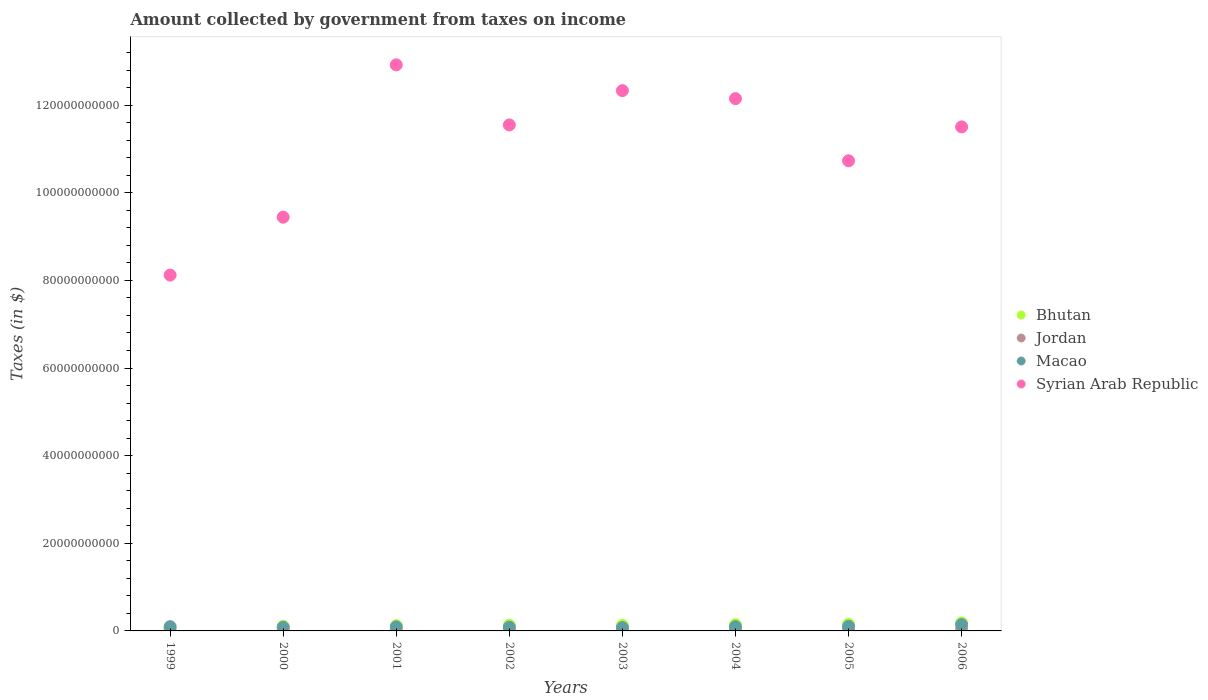How many different coloured dotlines are there?
Give a very brief answer. 4. Is the number of dotlines equal to the number of legend labels?
Your answer should be very brief. Yes. What is the amount collected by government from taxes on income in Syrian Arab Republic in 1999?
Give a very brief answer. 8.12e+1. Across all years, what is the maximum amount collected by government from taxes on income in Bhutan?
Give a very brief answer. 1.83e+09. Across all years, what is the minimum amount collected by government from taxes on income in Macao?
Offer a very short reply. 7.81e+08. What is the total amount collected by government from taxes on income in Bhutan in the graph?
Your answer should be very brief. 1.03e+1. What is the difference between the amount collected by government from taxes on income in Macao in 2000 and that in 2002?
Make the answer very short. -3.52e+07. What is the difference between the amount collected by government from taxes on income in Syrian Arab Republic in 2006 and the amount collected by government from taxes on income in Jordan in 2002?
Keep it short and to the point. 1.15e+11. What is the average amount collected by government from taxes on income in Macao per year?
Ensure brevity in your answer.  9.82e+08. In the year 2001, what is the difference between the amount collected by government from taxes on income in Bhutan and amount collected by government from taxes on income in Jordan?
Ensure brevity in your answer.  9.96e+08. What is the ratio of the amount collected by government from taxes on income in Jordan in 1999 to that in 2006?
Offer a very short reply. 0.37. What is the difference between the highest and the second highest amount collected by government from taxes on income in Syrian Arab Republic?
Offer a terse response. 5.89e+09. What is the difference between the highest and the lowest amount collected by government from taxes on income in Bhutan?
Ensure brevity in your answer.  1.11e+09. In how many years, is the amount collected by government from taxes on income in Bhutan greater than the average amount collected by government from taxes on income in Bhutan taken over all years?
Keep it short and to the point. 4. Is the amount collected by government from taxes on income in Macao strictly greater than the amount collected by government from taxes on income in Bhutan over the years?
Provide a short and direct response. No. Is the amount collected by government from taxes on income in Syrian Arab Republic strictly less than the amount collected by government from taxes on income in Macao over the years?
Ensure brevity in your answer.  No. How many dotlines are there?
Your answer should be very brief. 4. How many years are there in the graph?
Make the answer very short. 8. Are the values on the major ticks of Y-axis written in scientific E-notation?
Ensure brevity in your answer.  No. Does the graph contain grids?
Your response must be concise. No. How many legend labels are there?
Give a very brief answer. 4. What is the title of the graph?
Your answer should be very brief. Amount collected by government from taxes on income. Does "Chile" appear as one of the legend labels in the graph?
Your answer should be very brief. No. What is the label or title of the X-axis?
Offer a terse response. Years. What is the label or title of the Y-axis?
Ensure brevity in your answer.  Taxes (in $). What is the Taxes (in $) of Bhutan in 1999?
Offer a terse response. 7.25e+08. What is the Taxes (in $) in Jordan in 1999?
Offer a very short reply. 1.53e+08. What is the Taxes (in $) in Macao in 1999?
Make the answer very short. 9.76e+08. What is the Taxes (in $) of Syrian Arab Republic in 1999?
Your answer should be very brief. 8.12e+1. What is the Taxes (in $) in Bhutan in 2000?
Offer a terse response. 1.06e+09. What is the Taxes (in $) in Jordan in 2000?
Offer a very short reply. 1.61e+08. What is the Taxes (in $) in Macao in 2000?
Your response must be concise. 8.38e+08. What is the Taxes (in $) of Syrian Arab Republic in 2000?
Your answer should be compact. 9.44e+1. What is the Taxes (in $) in Bhutan in 2001?
Provide a succinct answer. 1.19e+09. What is the Taxes (in $) in Jordan in 2001?
Make the answer very short. 1.95e+08. What is the Taxes (in $) of Macao in 2001?
Provide a succinct answer. 9.24e+08. What is the Taxes (in $) in Syrian Arab Republic in 2001?
Offer a terse response. 1.29e+11. What is the Taxes (in $) of Bhutan in 2002?
Give a very brief answer. 1.31e+09. What is the Taxes (in $) of Jordan in 2002?
Your response must be concise. 1.96e+08. What is the Taxes (in $) of Macao in 2002?
Your answer should be compact. 8.73e+08. What is the Taxes (in $) of Syrian Arab Republic in 2002?
Give a very brief answer. 1.15e+11. What is the Taxes (in $) of Bhutan in 2003?
Give a very brief answer. 1.27e+09. What is the Taxes (in $) of Jordan in 2003?
Your response must be concise. 1.95e+08. What is the Taxes (in $) in Macao in 2003?
Offer a terse response. 7.81e+08. What is the Taxes (in $) of Syrian Arab Republic in 2003?
Offer a very short reply. 1.23e+11. What is the Taxes (in $) of Bhutan in 2004?
Your response must be concise. 1.42e+09. What is the Taxes (in $) in Jordan in 2004?
Offer a very short reply. 2.18e+08. What is the Taxes (in $) of Macao in 2004?
Provide a succinct answer. 9.68e+08. What is the Taxes (in $) in Syrian Arab Republic in 2004?
Offer a terse response. 1.21e+11. What is the Taxes (in $) of Bhutan in 2005?
Provide a short and direct response. 1.53e+09. What is the Taxes (in $) in Jordan in 2005?
Your answer should be very brief. 2.84e+08. What is the Taxes (in $) in Macao in 2005?
Keep it short and to the point. 1.05e+09. What is the Taxes (in $) in Syrian Arab Republic in 2005?
Your answer should be very brief. 1.07e+11. What is the Taxes (in $) of Bhutan in 2006?
Your answer should be compact. 1.83e+09. What is the Taxes (in $) of Jordan in 2006?
Offer a very short reply. 4.11e+08. What is the Taxes (in $) of Macao in 2006?
Offer a very short reply. 1.45e+09. What is the Taxes (in $) of Syrian Arab Republic in 2006?
Make the answer very short. 1.15e+11. Across all years, what is the maximum Taxes (in $) of Bhutan?
Offer a terse response. 1.83e+09. Across all years, what is the maximum Taxes (in $) in Jordan?
Ensure brevity in your answer.  4.11e+08. Across all years, what is the maximum Taxes (in $) in Macao?
Give a very brief answer. 1.45e+09. Across all years, what is the maximum Taxes (in $) of Syrian Arab Republic?
Your answer should be very brief. 1.29e+11. Across all years, what is the minimum Taxes (in $) of Bhutan?
Make the answer very short. 7.25e+08. Across all years, what is the minimum Taxes (in $) of Jordan?
Your answer should be compact. 1.53e+08. Across all years, what is the minimum Taxes (in $) in Macao?
Your response must be concise. 7.81e+08. Across all years, what is the minimum Taxes (in $) of Syrian Arab Republic?
Your answer should be compact. 8.12e+1. What is the total Taxes (in $) of Bhutan in the graph?
Provide a short and direct response. 1.03e+1. What is the total Taxes (in $) of Jordan in the graph?
Provide a short and direct response. 1.81e+09. What is the total Taxes (in $) of Macao in the graph?
Ensure brevity in your answer.  7.86e+09. What is the total Taxes (in $) in Syrian Arab Republic in the graph?
Make the answer very short. 8.87e+11. What is the difference between the Taxes (in $) of Bhutan in 1999 and that in 2000?
Keep it short and to the point. -3.32e+08. What is the difference between the Taxes (in $) of Jordan in 1999 and that in 2000?
Give a very brief answer. -8.20e+06. What is the difference between the Taxes (in $) of Macao in 1999 and that in 2000?
Your answer should be compact. 1.38e+08. What is the difference between the Taxes (in $) in Syrian Arab Republic in 1999 and that in 2000?
Your response must be concise. -1.32e+1. What is the difference between the Taxes (in $) of Bhutan in 1999 and that in 2001?
Provide a short and direct response. -4.67e+08. What is the difference between the Taxes (in $) of Jordan in 1999 and that in 2001?
Keep it short and to the point. -4.26e+07. What is the difference between the Taxes (in $) of Macao in 1999 and that in 2001?
Provide a succinct answer. 5.21e+07. What is the difference between the Taxes (in $) in Syrian Arab Republic in 1999 and that in 2001?
Make the answer very short. -4.80e+1. What is the difference between the Taxes (in $) in Bhutan in 1999 and that in 2002?
Keep it short and to the point. -5.80e+08. What is the difference between the Taxes (in $) of Jordan in 1999 and that in 2002?
Give a very brief answer. -4.34e+07. What is the difference between the Taxes (in $) of Macao in 1999 and that in 2002?
Offer a terse response. 1.03e+08. What is the difference between the Taxes (in $) of Syrian Arab Republic in 1999 and that in 2002?
Your answer should be compact. -3.43e+1. What is the difference between the Taxes (in $) in Bhutan in 1999 and that in 2003?
Ensure brevity in your answer.  -5.48e+08. What is the difference between the Taxes (in $) of Jordan in 1999 and that in 2003?
Keep it short and to the point. -4.26e+07. What is the difference between the Taxes (in $) in Macao in 1999 and that in 2003?
Offer a terse response. 1.95e+08. What is the difference between the Taxes (in $) in Syrian Arab Republic in 1999 and that in 2003?
Offer a very short reply. -4.21e+1. What is the difference between the Taxes (in $) in Bhutan in 1999 and that in 2004?
Offer a terse response. -6.94e+08. What is the difference between the Taxes (in $) in Jordan in 1999 and that in 2004?
Provide a short and direct response. -6.51e+07. What is the difference between the Taxes (in $) of Macao in 1999 and that in 2004?
Offer a terse response. 8.38e+06. What is the difference between the Taxes (in $) in Syrian Arab Republic in 1999 and that in 2004?
Provide a succinct answer. -4.03e+1. What is the difference between the Taxes (in $) of Bhutan in 1999 and that in 2005?
Your answer should be very brief. -8.05e+08. What is the difference between the Taxes (in $) of Jordan in 1999 and that in 2005?
Make the answer very short. -1.31e+08. What is the difference between the Taxes (in $) in Macao in 1999 and that in 2005?
Keep it short and to the point. -7.70e+07. What is the difference between the Taxes (in $) in Syrian Arab Republic in 1999 and that in 2005?
Your response must be concise. -2.61e+1. What is the difference between the Taxes (in $) of Bhutan in 1999 and that in 2006?
Make the answer very short. -1.11e+09. What is the difference between the Taxes (in $) in Jordan in 1999 and that in 2006?
Offer a very short reply. -2.59e+08. What is the difference between the Taxes (in $) of Macao in 1999 and that in 2006?
Keep it short and to the point. -4.70e+08. What is the difference between the Taxes (in $) of Syrian Arab Republic in 1999 and that in 2006?
Ensure brevity in your answer.  -3.38e+1. What is the difference between the Taxes (in $) of Bhutan in 2000 and that in 2001?
Your response must be concise. -1.35e+08. What is the difference between the Taxes (in $) in Jordan in 2000 and that in 2001?
Make the answer very short. -3.44e+07. What is the difference between the Taxes (in $) of Macao in 2000 and that in 2001?
Keep it short and to the point. -8.57e+07. What is the difference between the Taxes (in $) of Syrian Arab Republic in 2000 and that in 2001?
Your answer should be compact. -3.48e+1. What is the difference between the Taxes (in $) in Bhutan in 2000 and that in 2002?
Keep it short and to the point. -2.48e+08. What is the difference between the Taxes (in $) of Jordan in 2000 and that in 2002?
Your answer should be compact. -3.52e+07. What is the difference between the Taxes (in $) in Macao in 2000 and that in 2002?
Offer a very short reply. -3.52e+07. What is the difference between the Taxes (in $) in Syrian Arab Republic in 2000 and that in 2002?
Your response must be concise. -2.11e+1. What is the difference between the Taxes (in $) of Bhutan in 2000 and that in 2003?
Offer a very short reply. -2.16e+08. What is the difference between the Taxes (in $) of Jordan in 2000 and that in 2003?
Make the answer very short. -3.44e+07. What is the difference between the Taxes (in $) in Macao in 2000 and that in 2003?
Make the answer very short. 5.73e+07. What is the difference between the Taxes (in $) of Syrian Arab Republic in 2000 and that in 2003?
Give a very brief answer. -2.89e+1. What is the difference between the Taxes (in $) in Bhutan in 2000 and that in 2004?
Make the answer very short. -3.63e+08. What is the difference between the Taxes (in $) of Jordan in 2000 and that in 2004?
Offer a terse response. -5.69e+07. What is the difference between the Taxes (in $) in Macao in 2000 and that in 2004?
Your answer should be very brief. -1.29e+08. What is the difference between the Taxes (in $) in Syrian Arab Republic in 2000 and that in 2004?
Keep it short and to the point. -2.71e+1. What is the difference between the Taxes (in $) of Bhutan in 2000 and that in 2005?
Provide a succinct answer. -4.73e+08. What is the difference between the Taxes (in $) of Jordan in 2000 and that in 2005?
Provide a short and direct response. -1.23e+08. What is the difference between the Taxes (in $) of Macao in 2000 and that in 2005?
Ensure brevity in your answer.  -2.15e+08. What is the difference between the Taxes (in $) of Syrian Arab Republic in 2000 and that in 2005?
Provide a succinct answer. -1.29e+1. What is the difference between the Taxes (in $) of Bhutan in 2000 and that in 2006?
Your answer should be very brief. -7.76e+08. What is the difference between the Taxes (in $) of Jordan in 2000 and that in 2006?
Ensure brevity in your answer.  -2.50e+08. What is the difference between the Taxes (in $) in Macao in 2000 and that in 2006?
Give a very brief answer. -6.08e+08. What is the difference between the Taxes (in $) in Syrian Arab Republic in 2000 and that in 2006?
Keep it short and to the point. -2.06e+1. What is the difference between the Taxes (in $) in Bhutan in 2001 and that in 2002?
Provide a short and direct response. -1.13e+08. What is the difference between the Taxes (in $) of Jordan in 2001 and that in 2002?
Your response must be concise. -8.00e+05. What is the difference between the Taxes (in $) of Macao in 2001 and that in 2002?
Your answer should be very brief. 5.05e+07. What is the difference between the Taxes (in $) of Syrian Arab Republic in 2001 and that in 2002?
Provide a short and direct response. 1.37e+1. What is the difference between the Taxes (in $) of Bhutan in 2001 and that in 2003?
Ensure brevity in your answer.  -8.09e+07. What is the difference between the Taxes (in $) of Macao in 2001 and that in 2003?
Provide a short and direct response. 1.43e+08. What is the difference between the Taxes (in $) in Syrian Arab Republic in 2001 and that in 2003?
Your answer should be very brief. 5.89e+09. What is the difference between the Taxes (in $) in Bhutan in 2001 and that in 2004?
Offer a very short reply. -2.28e+08. What is the difference between the Taxes (in $) in Jordan in 2001 and that in 2004?
Your answer should be compact. -2.25e+07. What is the difference between the Taxes (in $) in Macao in 2001 and that in 2004?
Give a very brief answer. -4.38e+07. What is the difference between the Taxes (in $) of Syrian Arab Republic in 2001 and that in 2004?
Provide a succinct answer. 7.71e+09. What is the difference between the Taxes (in $) in Bhutan in 2001 and that in 2005?
Make the answer very short. -3.38e+08. What is the difference between the Taxes (in $) in Jordan in 2001 and that in 2005?
Offer a terse response. -8.83e+07. What is the difference between the Taxes (in $) in Macao in 2001 and that in 2005?
Offer a very short reply. -1.29e+08. What is the difference between the Taxes (in $) in Syrian Arab Republic in 2001 and that in 2005?
Offer a very short reply. 2.19e+1. What is the difference between the Taxes (in $) in Bhutan in 2001 and that in 2006?
Your answer should be very brief. -6.41e+08. What is the difference between the Taxes (in $) of Jordan in 2001 and that in 2006?
Your answer should be very brief. -2.16e+08. What is the difference between the Taxes (in $) in Macao in 2001 and that in 2006?
Give a very brief answer. -5.22e+08. What is the difference between the Taxes (in $) in Syrian Arab Republic in 2001 and that in 2006?
Your response must be concise. 1.42e+1. What is the difference between the Taxes (in $) of Bhutan in 2002 and that in 2003?
Your answer should be compact. 3.24e+07. What is the difference between the Taxes (in $) of Jordan in 2002 and that in 2003?
Offer a terse response. 8.20e+05. What is the difference between the Taxes (in $) in Macao in 2002 and that in 2003?
Provide a short and direct response. 9.25e+07. What is the difference between the Taxes (in $) in Syrian Arab Republic in 2002 and that in 2003?
Offer a very short reply. -7.82e+09. What is the difference between the Taxes (in $) in Bhutan in 2002 and that in 2004?
Give a very brief answer. -1.14e+08. What is the difference between the Taxes (in $) in Jordan in 2002 and that in 2004?
Your answer should be very brief. -2.17e+07. What is the difference between the Taxes (in $) in Macao in 2002 and that in 2004?
Provide a succinct answer. -9.42e+07. What is the difference between the Taxes (in $) of Syrian Arab Republic in 2002 and that in 2004?
Your answer should be very brief. -6.00e+09. What is the difference between the Taxes (in $) of Bhutan in 2002 and that in 2005?
Ensure brevity in your answer.  -2.25e+08. What is the difference between the Taxes (in $) in Jordan in 2002 and that in 2005?
Make the answer very short. -8.75e+07. What is the difference between the Taxes (in $) of Macao in 2002 and that in 2005?
Provide a short and direct response. -1.80e+08. What is the difference between the Taxes (in $) of Syrian Arab Republic in 2002 and that in 2005?
Your answer should be compact. 8.18e+09. What is the difference between the Taxes (in $) of Bhutan in 2002 and that in 2006?
Make the answer very short. -5.28e+08. What is the difference between the Taxes (in $) in Jordan in 2002 and that in 2006?
Ensure brevity in your answer.  -2.15e+08. What is the difference between the Taxes (in $) in Macao in 2002 and that in 2006?
Your answer should be compact. -5.73e+08. What is the difference between the Taxes (in $) in Syrian Arab Republic in 2002 and that in 2006?
Keep it short and to the point. 4.52e+08. What is the difference between the Taxes (in $) of Bhutan in 2003 and that in 2004?
Keep it short and to the point. -1.47e+08. What is the difference between the Taxes (in $) of Jordan in 2003 and that in 2004?
Provide a succinct answer. -2.25e+07. What is the difference between the Taxes (in $) of Macao in 2003 and that in 2004?
Your answer should be very brief. -1.87e+08. What is the difference between the Taxes (in $) in Syrian Arab Republic in 2003 and that in 2004?
Your answer should be very brief. 1.83e+09. What is the difference between the Taxes (in $) of Bhutan in 2003 and that in 2005?
Offer a very short reply. -2.57e+08. What is the difference between the Taxes (in $) of Jordan in 2003 and that in 2005?
Provide a succinct answer. -8.83e+07. What is the difference between the Taxes (in $) in Macao in 2003 and that in 2005?
Your response must be concise. -2.72e+08. What is the difference between the Taxes (in $) in Syrian Arab Republic in 2003 and that in 2005?
Offer a terse response. 1.60e+1. What is the difference between the Taxes (in $) of Bhutan in 2003 and that in 2006?
Your response must be concise. -5.61e+08. What is the difference between the Taxes (in $) of Jordan in 2003 and that in 2006?
Provide a short and direct response. -2.16e+08. What is the difference between the Taxes (in $) of Macao in 2003 and that in 2006?
Offer a very short reply. -6.65e+08. What is the difference between the Taxes (in $) of Syrian Arab Republic in 2003 and that in 2006?
Provide a short and direct response. 8.27e+09. What is the difference between the Taxes (in $) of Bhutan in 2004 and that in 2005?
Give a very brief answer. -1.10e+08. What is the difference between the Taxes (in $) in Jordan in 2004 and that in 2005?
Keep it short and to the point. -6.58e+07. What is the difference between the Taxes (in $) in Macao in 2004 and that in 2005?
Offer a very short reply. -8.54e+07. What is the difference between the Taxes (in $) of Syrian Arab Republic in 2004 and that in 2005?
Offer a very short reply. 1.42e+1. What is the difference between the Taxes (in $) of Bhutan in 2004 and that in 2006?
Offer a very short reply. -4.14e+08. What is the difference between the Taxes (in $) of Jordan in 2004 and that in 2006?
Ensure brevity in your answer.  -1.94e+08. What is the difference between the Taxes (in $) in Macao in 2004 and that in 2006?
Make the answer very short. -4.78e+08. What is the difference between the Taxes (in $) in Syrian Arab Republic in 2004 and that in 2006?
Your answer should be compact. 6.45e+09. What is the difference between the Taxes (in $) in Bhutan in 2005 and that in 2006?
Offer a terse response. -3.03e+08. What is the difference between the Taxes (in $) in Jordan in 2005 and that in 2006?
Provide a succinct answer. -1.28e+08. What is the difference between the Taxes (in $) of Macao in 2005 and that in 2006?
Provide a short and direct response. -3.93e+08. What is the difference between the Taxes (in $) in Syrian Arab Republic in 2005 and that in 2006?
Provide a short and direct response. -7.73e+09. What is the difference between the Taxes (in $) of Bhutan in 1999 and the Taxes (in $) of Jordan in 2000?
Your answer should be compact. 5.64e+08. What is the difference between the Taxes (in $) of Bhutan in 1999 and the Taxes (in $) of Macao in 2000?
Provide a short and direct response. -1.13e+08. What is the difference between the Taxes (in $) in Bhutan in 1999 and the Taxes (in $) in Syrian Arab Republic in 2000?
Offer a very short reply. -9.37e+1. What is the difference between the Taxes (in $) in Jordan in 1999 and the Taxes (in $) in Macao in 2000?
Give a very brief answer. -6.85e+08. What is the difference between the Taxes (in $) in Jordan in 1999 and the Taxes (in $) in Syrian Arab Republic in 2000?
Your response must be concise. -9.43e+1. What is the difference between the Taxes (in $) in Macao in 1999 and the Taxes (in $) in Syrian Arab Republic in 2000?
Make the answer very short. -9.34e+1. What is the difference between the Taxes (in $) of Bhutan in 1999 and the Taxes (in $) of Jordan in 2001?
Your response must be concise. 5.30e+08. What is the difference between the Taxes (in $) of Bhutan in 1999 and the Taxes (in $) of Macao in 2001?
Ensure brevity in your answer.  -1.99e+08. What is the difference between the Taxes (in $) of Bhutan in 1999 and the Taxes (in $) of Syrian Arab Republic in 2001?
Your response must be concise. -1.28e+11. What is the difference between the Taxes (in $) in Jordan in 1999 and the Taxes (in $) in Macao in 2001?
Your answer should be very brief. -7.71e+08. What is the difference between the Taxes (in $) in Jordan in 1999 and the Taxes (in $) in Syrian Arab Republic in 2001?
Your answer should be compact. -1.29e+11. What is the difference between the Taxes (in $) of Macao in 1999 and the Taxes (in $) of Syrian Arab Republic in 2001?
Provide a succinct answer. -1.28e+11. What is the difference between the Taxes (in $) of Bhutan in 1999 and the Taxes (in $) of Jordan in 2002?
Ensure brevity in your answer.  5.29e+08. What is the difference between the Taxes (in $) in Bhutan in 1999 and the Taxes (in $) in Macao in 2002?
Make the answer very short. -1.48e+08. What is the difference between the Taxes (in $) in Bhutan in 1999 and the Taxes (in $) in Syrian Arab Republic in 2002?
Provide a short and direct response. -1.15e+11. What is the difference between the Taxes (in $) in Jordan in 1999 and the Taxes (in $) in Macao in 2002?
Provide a short and direct response. -7.21e+08. What is the difference between the Taxes (in $) in Jordan in 1999 and the Taxes (in $) in Syrian Arab Republic in 2002?
Provide a short and direct response. -1.15e+11. What is the difference between the Taxes (in $) of Macao in 1999 and the Taxes (in $) of Syrian Arab Republic in 2002?
Offer a very short reply. -1.14e+11. What is the difference between the Taxes (in $) of Bhutan in 1999 and the Taxes (in $) of Jordan in 2003?
Offer a very short reply. 5.30e+08. What is the difference between the Taxes (in $) of Bhutan in 1999 and the Taxes (in $) of Macao in 2003?
Offer a terse response. -5.58e+07. What is the difference between the Taxes (in $) in Bhutan in 1999 and the Taxes (in $) in Syrian Arab Republic in 2003?
Your answer should be very brief. -1.23e+11. What is the difference between the Taxes (in $) in Jordan in 1999 and the Taxes (in $) in Macao in 2003?
Keep it short and to the point. -6.28e+08. What is the difference between the Taxes (in $) of Jordan in 1999 and the Taxes (in $) of Syrian Arab Republic in 2003?
Offer a terse response. -1.23e+11. What is the difference between the Taxes (in $) in Macao in 1999 and the Taxes (in $) in Syrian Arab Republic in 2003?
Provide a short and direct response. -1.22e+11. What is the difference between the Taxes (in $) in Bhutan in 1999 and the Taxes (in $) in Jordan in 2004?
Offer a very short reply. 5.07e+08. What is the difference between the Taxes (in $) of Bhutan in 1999 and the Taxes (in $) of Macao in 2004?
Provide a short and direct response. -2.43e+08. What is the difference between the Taxes (in $) in Bhutan in 1999 and the Taxes (in $) in Syrian Arab Republic in 2004?
Give a very brief answer. -1.21e+11. What is the difference between the Taxes (in $) of Jordan in 1999 and the Taxes (in $) of Macao in 2004?
Ensure brevity in your answer.  -8.15e+08. What is the difference between the Taxes (in $) in Jordan in 1999 and the Taxes (in $) in Syrian Arab Republic in 2004?
Provide a succinct answer. -1.21e+11. What is the difference between the Taxes (in $) in Macao in 1999 and the Taxes (in $) in Syrian Arab Republic in 2004?
Your answer should be very brief. -1.20e+11. What is the difference between the Taxes (in $) of Bhutan in 1999 and the Taxes (in $) of Jordan in 2005?
Your response must be concise. 4.41e+08. What is the difference between the Taxes (in $) in Bhutan in 1999 and the Taxes (in $) in Macao in 2005?
Your answer should be compact. -3.28e+08. What is the difference between the Taxes (in $) of Bhutan in 1999 and the Taxes (in $) of Syrian Arab Republic in 2005?
Offer a terse response. -1.07e+11. What is the difference between the Taxes (in $) of Jordan in 1999 and the Taxes (in $) of Macao in 2005?
Give a very brief answer. -9.00e+08. What is the difference between the Taxes (in $) in Jordan in 1999 and the Taxes (in $) in Syrian Arab Republic in 2005?
Ensure brevity in your answer.  -1.07e+11. What is the difference between the Taxes (in $) in Macao in 1999 and the Taxes (in $) in Syrian Arab Republic in 2005?
Your answer should be very brief. -1.06e+11. What is the difference between the Taxes (in $) of Bhutan in 1999 and the Taxes (in $) of Jordan in 2006?
Provide a succinct answer. 3.14e+08. What is the difference between the Taxes (in $) of Bhutan in 1999 and the Taxes (in $) of Macao in 2006?
Your answer should be very brief. -7.21e+08. What is the difference between the Taxes (in $) of Bhutan in 1999 and the Taxes (in $) of Syrian Arab Republic in 2006?
Ensure brevity in your answer.  -1.14e+11. What is the difference between the Taxes (in $) in Jordan in 1999 and the Taxes (in $) in Macao in 2006?
Your response must be concise. -1.29e+09. What is the difference between the Taxes (in $) of Jordan in 1999 and the Taxes (in $) of Syrian Arab Republic in 2006?
Make the answer very short. -1.15e+11. What is the difference between the Taxes (in $) of Macao in 1999 and the Taxes (in $) of Syrian Arab Republic in 2006?
Provide a short and direct response. -1.14e+11. What is the difference between the Taxes (in $) in Bhutan in 2000 and the Taxes (in $) in Jordan in 2001?
Make the answer very short. 8.61e+08. What is the difference between the Taxes (in $) in Bhutan in 2000 and the Taxes (in $) in Macao in 2001?
Your answer should be compact. 1.33e+08. What is the difference between the Taxes (in $) of Bhutan in 2000 and the Taxes (in $) of Syrian Arab Republic in 2001?
Offer a terse response. -1.28e+11. What is the difference between the Taxes (in $) of Jordan in 2000 and the Taxes (in $) of Macao in 2001?
Your response must be concise. -7.63e+08. What is the difference between the Taxes (in $) in Jordan in 2000 and the Taxes (in $) in Syrian Arab Republic in 2001?
Keep it short and to the point. -1.29e+11. What is the difference between the Taxes (in $) in Macao in 2000 and the Taxes (in $) in Syrian Arab Republic in 2001?
Give a very brief answer. -1.28e+11. What is the difference between the Taxes (in $) of Bhutan in 2000 and the Taxes (in $) of Jordan in 2002?
Give a very brief answer. 8.60e+08. What is the difference between the Taxes (in $) of Bhutan in 2000 and the Taxes (in $) of Macao in 2002?
Provide a short and direct response. 1.83e+08. What is the difference between the Taxes (in $) of Bhutan in 2000 and the Taxes (in $) of Syrian Arab Republic in 2002?
Your answer should be very brief. -1.14e+11. What is the difference between the Taxes (in $) in Jordan in 2000 and the Taxes (in $) in Macao in 2002?
Your answer should be compact. -7.12e+08. What is the difference between the Taxes (in $) in Jordan in 2000 and the Taxes (in $) in Syrian Arab Republic in 2002?
Your answer should be very brief. -1.15e+11. What is the difference between the Taxes (in $) in Macao in 2000 and the Taxes (in $) in Syrian Arab Republic in 2002?
Give a very brief answer. -1.15e+11. What is the difference between the Taxes (in $) of Bhutan in 2000 and the Taxes (in $) of Jordan in 2003?
Keep it short and to the point. 8.61e+08. What is the difference between the Taxes (in $) of Bhutan in 2000 and the Taxes (in $) of Macao in 2003?
Offer a very short reply. 2.76e+08. What is the difference between the Taxes (in $) of Bhutan in 2000 and the Taxes (in $) of Syrian Arab Republic in 2003?
Offer a very short reply. -1.22e+11. What is the difference between the Taxes (in $) of Jordan in 2000 and the Taxes (in $) of Macao in 2003?
Provide a short and direct response. -6.20e+08. What is the difference between the Taxes (in $) in Jordan in 2000 and the Taxes (in $) in Syrian Arab Republic in 2003?
Offer a terse response. -1.23e+11. What is the difference between the Taxes (in $) in Macao in 2000 and the Taxes (in $) in Syrian Arab Republic in 2003?
Offer a very short reply. -1.22e+11. What is the difference between the Taxes (in $) of Bhutan in 2000 and the Taxes (in $) of Jordan in 2004?
Ensure brevity in your answer.  8.39e+08. What is the difference between the Taxes (in $) in Bhutan in 2000 and the Taxes (in $) in Macao in 2004?
Make the answer very short. 8.91e+07. What is the difference between the Taxes (in $) of Bhutan in 2000 and the Taxes (in $) of Syrian Arab Republic in 2004?
Offer a very short reply. -1.20e+11. What is the difference between the Taxes (in $) of Jordan in 2000 and the Taxes (in $) of Macao in 2004?
Keep it short and to the point. -8.07e+08. What is the difference between the Taxes (in $) in Jordan in 2000 and the Taxes (in $) in Syrian Arab Republic in 2004?
Give a very brief answer. -1.21e+11. What is the difference between the Taxes (in $) in Macao in 2000 and the Taxes (in $) in Syrian Arab Republic in 2004?
Provide a succinct answer. -1.21e+11. What is the difference between the Taxes (in $) of Bhutan in 2000 and the Taxes (in $) of Jordan in 2005?
Your answer should be very brief. 7.73e+08. What is the difference between the Taxes (in $) of Bhutan in 2000 and the Taxes (in $) of Macao in 2005?
Provide a succinct answer. 3.70e+06. What is the difference between the Taxes (in $) of Bhutan in 2000 and the Taxes (in $) of Syrian Arab Republic in 2005?
Ensure brevity in your answer.  -1.06e+11. What is the difference between the Taxes (in $) in Jordan in 2000 and the Taxes (in $) in Macao in 2005?
Your answer should be very brief. -8.92e+08. What is the difference between the Taxes (in $) in Jordan in 2000 and the Taxes (in $) in Syrian Arab Republic in 2005?
Make the answer very short. -1.07e+11. What is the difference between the Taxes (in $) of Macao in 2000 and the Taxes (in $) of Syrian Arab Republic in 2005?
Your answer should be compact. -1.06e+11. What is the difference between the Taxes (in $) of Bhutan in 2000 and the Taxes (in $) of Jordan in 2006?
Provide a short and direct response. 6.45e+08. What is the difference between the Taxes (in $) in Bhutan in 2000 and the Taxes (in $) in Macao in 2006?
Make the answer very short. -3.89e+08. What is the difference between the Taxes (in $) of Bhutan in 2000 and the Taxes (in $) of Syrian Arab Republic in 2006?
Your response must be concise. -1.14e+11. What is the difference between the Taxes (in $) of Jordan in 2000 and the Taxes (in $) of Macao in 2006?
Give a very brief answer. -1.29e+09. What is the difference between the Taxes (in $) in Jordan in 2000 and the Taxes (in $) in Syrian Arab Republic in 2006?
Ensure brevity in your answer.  -1.15e+11. What is the difference between the Taxes (in $) in Macao in 2000 and the Taxes (in $) in Syrian Arab Republic in 2006?
Your response must be concise. -1.14e+11. What is the difference between the Taxes (in $) of Bhutan in 2001 and the Taxes (in $) of Jordan in 2002?
Your answer should be compact. 9.96e+08. What is the difference between the Taxes (in $) of Bhutan in 2001 and the Taxes (in $) of Macao in 2002?
Provide a succinct answer. 3.18e+08. What is the difference between the Taxes (in $) of Bhutan in 2001 and the Taxes (in $) of Syrian Arab Republic in 2002?
Ensure brevity in your answer.  -1.14e+11. What is the difference between the Taxes (in $) in Jordan in 2001 and the Taxes (in $) in Macao in 2002?
Offer a very short reply. -6.78e+08. What is the difference between the Taxes (in $) of Jordan in 2001 and the Taxes (in $) of Syrian Arab Republic in 2002?
Ensure brevity in your answer.  -1.15e+11. What is the difference between the Taxes (in $) of Macao in 2001 and the Taxes (in $) of Syrian Arab Republic in 2002?
Your answer should be very brief. -1.15e+11. What is the difference between the Taxes (in $) in Bhutan in 2001 and the Taxes (in $) in Jordan in 2003?
Your answer should be compact. 9.96e+08. What is the difference between the Taxes (in $) of Bhutan in 2001 and the Taxes (in $) of Macao in 2003?
Keep it short and to the point. 4.11e+08. What is the difference between the Taxes (in $) in Bhutan in 2001 and the Taxes (in $) in Syrian Arab Republic in 2003?
Give a very brief answer. -1.22e+11. What is the difference between the Taxes (in $) of Jordan in 2001 and the Taxes (in $) of Macao in 2003?
Offer a very short reply. -5.85e+08. What is the difference between the Taxes (in $) in Jordan in 2001 and the Taxes (in $) in Syrian Arab Republic in 2003?
Your answer should be compact. -1.23e+11. What is the difference between the Taxes (in $) in Macao in 2001 and the Taxes (in $) in Syrian Arab Republic in 2003?
Ensure brevity in your answer.  -1.22e+11. What is the difference between the Taxes (in $) in Bhutan in 2001 and the Taxes (in $) in Jordan in 2004?
Provide a succinct answer. 9.74e+08. What is the difference between the Taxes (in $) of Bhutan in 2001 and the Taxes (in $) of Macao in 2004?
Offer a very short reply. 2.24e+08. What is the difference between the Taxes (in $) in Bhutan in 2001 and the Taxes (in $) in Syrian Arab Republic in 2004?
Make the answer very short. -1.20e+11. What is the difference between the Taxes (in $) of Jordan in 2001 and the Taxes (in $) of Macao in 2004?
Offer a terse response. -7.72e+08. What is the difference between the Taxes (in $) of Jordan in 2001 and the Taxes (in $) of Syrian Arab Republic in 2004?
Your answer should be very brief. -1.21e+11. What is the difference between the Taxes (in $) in Macao in 2001 and the Taxes (in $) in Syrian Arab Republic in 2004?
Ensure brevity in your answer.  -1.21e+11. What is the difference between the Taxes (in $) of Bhutan in 2001 and the Taxes (in $) of Jordan in 2005?
Your answer should be very brief. 9.08e+08. What is the difference between the Taxes (in $) in Bhutan in 2001 and the Taxes (in $) in Macao in 2005?
Make the answer very short. 1.39e+08. What is the difference between the Taxes (in $) of Bhutan in 2001 and the Taxes (in $) of Syrian Arab Republic in 2005?
Make the answer very short. -1.06e+11. What is the difference between the Taxes (in $) in Jordan in 2001 and the Taxes (in $) in Macao in 2005?
Your answer should be very brief. -8.58e+08. What is the difference between the Taxes (in $) in Jordan in 2001 and the Taxes (in $) in Syrian Arab Republic in 2005?
Ensure brevity in your answer.  -1.07e+11. What is the difference between the Taxes (in $) in Macao in 2001 and the Taxes (in $) in Syrian Arab Republic in 2005?
Offer a terse response. -1.06e+11. What is the difference between the Taxes (in $) of Bhutan in 2001 and the Taxes (in $) of Jordan in 2006?
Offer a terse response. 7.80e+08. What is the difference between the Taxes (in $) in Bhutan in 2001 and the Taxes (in $) in Macao in 2006?
Give a very brief answer. -2.54e+08. What is the difference between the Taxes (in $) in Bhutan in 2001 and the Taxes (in $) in Syrian Arab Republic in 2006?
Your response must be concise. -1.14e+11. What is the difference between the Taxes (in $) of Jordan in 2001 and the Taxes (in $) of Macao in 2006?
Make the answer very short. -1.25e+09. What is the difference between the Taxes (in $) in Jordan in 2001 and the Taxes (in $) in Syrian Arab Republic in 2006?
Make the answer very short. -1.15e+11. What is the difference between the Taxes (in $) of Macao in 2001 and the Taxes (in $) of Syrian Arab Republic in 2006?
Ensure brevity in your answer.  -1.14e+11. What is the difference between the Taxes (in $) in Bhutan in 2002 and the Taxes (in $) in Jordan in 2003?
Offer a terse response. 1.11e+09. What is the difference between the Taxes (in $) of Bhutan in 2002 and the Taxes (in $) of Macao in 2003?
Ensure brevity in your answer.  5.24e+08. What is the difference between the Taxes (in $) in Bhutan in 2002 and the Taxes (in $) in Syrian Arab Republic in 2003?
Offer a very short reply. -1.22e+11. What is the difference between the Taxes (in $) of Jordan in 2002 and the Taxes (in $) of Macao in 2003?
Offer a terse response. -5.85e+08. What is the difference between the Taxes (in $) of Jordan in 2002 and the Taxes (in $) of Syrian Arab Republic in 2003?
Give a very brief answer. -1.23e+11. What is the difference between the Taxes (in $) in Macao in 2002 and the Taxes (in $) in Syrian Arab Republic in 2003?
Make the answer very short. -1.22e+11. What is the difference between the Taxes (in $) in Bhutan in 2002 and the Taxes (in $) in Jordan in 2004?
Provide a short and direct response. 1.09e+09. What is the difference between the Taxes (in $) in Bhutan in 2002 and the Taxes (in $) in Macao in 2004?
Give a very brief answer. 3.37e+08. What is the difference between the Taxes (in $) in Bhutan in 2002 and the Taxes (in $) in Syrian Arab Republic in 2004?
Your answer should be very brief. -1.20e+11. What is the difference between the Taxes (in $) of Jordan in 2002 and the Taxes (in $) of Macao in 2004?
Your answer should be very brief. -7.71e+08. What is the difference between the Taxes (in $) of Jordan in 2002 and the Taxes (in $) of Syrian Arab Republic in 2004?
Ensure brevity in your answer.  -1.21e+11. What is the difference between the Taxes (in $) of Macao in 2002 and the Taxes (in $) of Syrian Arab Republic in 2004?
Your response must be concise. -1.21e+11. What is the difference between the Taxes (in $) in Bhutan in 2002 and the Taxes (in $) in Jordan in 2005?
Provide a short and direct response. 1.02e+09. What is the difference between the Taxes (in $) in Bhutan in 2002 and the Taxes (in $) in Macao in 2005?
Give a very brief answer. 2.52e+08. What is the difference between the Taxes (in $) in Bhutan in 2002 and the Taxes (in $) in Syrian Arab Republic in 2005?
Your response must be concise. -1.06e+11. What is the difference between the Taxes (in $) of Jordan in 2002 and the Taxes (in $) of Macao in 2005?
Provide a succinct answer. -8.57e+08. What is the difference between the Taxes (in $) of Jordan in 2002 and the Taxes (in $) of Syrian Arab Republic in 2005?
Your answer should be compact. -1.07e+11. What is the difference between the Taxes (in $) in Macao in 2002 and the Taxes (in $) in Syrian Arab Republic in 2005?
Your answer should be compact. -1.06e+11. What is the difference between the Taxes (in $) in Bhutan in 2002 and the Taxes (in $) in Jordan in 2006?
Ensure brevity in your answer.  8.94e+08. What is the difference between the Taxes (in $) of Bhutan in 2002 and the Taxes (in $) of Macao in 2006?
Ensure brevity in your answer.  -1.41e+08. What is the difference between the Taxes (in $) in Bhutan in 2002 and the Taxes (in $) in Syrian Arab Republic in 2006?
Provide a succinct answer. -1.14e+11. What is the difference between the Taxes (in $) of Jordan in 2002 and the Taxes (in $) of Macao in 2006?
Provide a succinct answer. -1.25e+09. What is the difference between the Taxes (in $) of Jordan in 2002 and the Taxes (in $) of Syrian Arab Republic in 2006?
Give a very brief answer. -1.15e+11. What is the difference between the Taxes (in $) in Macao in 2002 and the Taxes (in $) in Syrian Arab Republic in 2006?
Offer a terse response. -1.14e+11. What is the difference between the Taxes (in $) in Bhutan in 2003 and the Taxes (in $) in Jordan in 2004?
Provide a succinct answer. 1.05e+09. What is the difference between the Taxes (in $) of Bhutan in 2003 and the Taxes (in $) of Macao in 2004?
Provide a short and direct response. 3.05e+08. What is the difference between the Taxes (in $) of Bhutan in 2003 and the Taxes (in $) of Syrian Arab Republic in 2004?
Your answer should be very brief. -1.20e+11. What is the difference between the Taxes (in $) in Jordan in 2003 and the Taxes (in $) in Macao in 2004?
Make the answer very short. -7.72e+08. What is the difference between the Taxes (in $) of Jordan in 2003 and the Taxes (in $) of Syrian Arab Republic in 2004?
Offer a terse response. -1.21e+11. What is the difference between the Taxes (in $) in Macao in 2003 and the Taxes (in $) in Syrian Arab Republic in 2004?
Provide a short and direct response. -1.21e+11. What is the difference between the Taxes (in $) of Bhutan in 2003 and the Taxes (in $) of Jordan in 2005?
Offer a very short reply. 9.89e+08. What is the difference between the Taxes (in $) in Bhutan in 2003 and the Taxes (in $) in Macao in 2005?
Make the answer very short. 2.20e+08. What is the difference between the Taxes (in $) in Bhutan in 2003 and the Taxes (in $) in Syrian Arab Republic in 2005?
Give a very brief answer. -1.06e+11. What is the difference between the Taxes (in $) in Jordan in 2003 and the Taxes (in $) in Macao in 2005?
Make the answer very short. -8.58e+08. What is the difference between the Taxes (in $) of Jordan in 2003 and the Taxes (in $) of Syrian Arab Republic in 2005?
Provide a short and direct response. -1.07e+11. What is the difference between the Taxes (in $) of Macao in 2003 and the Taxes (in $) of Syrian Arab Republic in 2005?
Offer a very short reply. -1.07e+11. What is the difference between the Taxes (in $) in Bhutan in 2003 and the Taxes (in $) in Jordan in 2006?
Your answer should be very brief. 8.61e+08. What is the difference between the Taxes (in $) of Bhutan in 2003 and the Taxes (in $) of Macao in 2006?
Provide a short and direct response. -1.73e+08. What is the difference between the Taxes (in $) of Bhutan in 2003 and the Taxes (in $) of Syrian Arab Republic in 2006?
Offer a very short reply. -1.14e+11. What is the difference between the Taxes (in $) in Jordan in 2003 and the Taxes (in $) in Macao in 2006?
Your answer should be very brief. -1.25e+09. What is the difference between the Taxes (in $) in Jordan in 2003 and the Taxes (in $) in Syrian Arab Republic in 2006?
Your answer should be very brief. -1.15e+11. What is the difference between the Taxes (in $) in Macao in 2003 and the Taxes (in $) in Syrian Arab Republic in 2006?
Provide a short and direct response. -1.14e+11. What is the difference between the Taxes (in $) of Bhutan in 2004 and the Taxes (in $) of Jordan in 2005?
Your answer should be compact. 1.14e+09. What is the difference between the Taxes (in $) in Bhutan in 2004 and the Taxes (in $) in Macao in 2005?
Give a very brief answer. 3.66e+08. What is the difference between the Taxes (in $) in Bhutan in 2004 and the Taxes (in $) in Syrian Arab Republic in 2005?
Provide a succinct answer. -1.06e+11. What is the difference between the Taxes (in $) of Jordan in 2004 and the Taxes (in $) of Macao in 2005?
Your response must be concise. -8.35e+08. What is the difference between the Taxes (in $) of Jordan in 2004 and the Taxes (in $) of Syrian Arab Republic in 2005?
Provide a short and direct response. -1.07e+11. What is the difference between the Taxes (in $) in Macao in 2004 and the Taxes (in $) in Syrian Arab Republic in 2005?
Your answer should be very brief. -1.06e+11. What is the difference between the Taxes (in $) of Bhutan in 2004 and the Taxes (in $) of Jordan in 2006?
Provide a short and direct response. 1.01e+09. What is the difference between the Taxes (in $) in Bhutan in 2004 and the Taxes (in $) in Macao in 2006?
Your answer should be compact. -2.66e+07. What is the difference between the Taxes (in $) of Bhutan in 2004 and the Taxes (in $) of Syrian Arab Republic in 2006?
Ensure brevity in your answer.  -1.14e+11. What is the difference between the Taxes (in $) in Jordan in 2004 and the Taxes (in $) in Macao in 2006?
Your answer should be compact. -1.23e+09. What is the difference between the Taxes (in $) of Jordan in 2004 and the Taxes (in $) of Syrian Arab Republic in 2006?
Offer a very short reply. -1.15e+11. What is the difference between the Taxes (in $) of Macao in 2004 and the Taxes (in $) of Syrian Arab Republic in 2006?
Give a very brief answer. -1.14e+11. What is the difference between the Taxes (in $) in Bhutan in 2005 and the Taxes (in $) in Jordan in 2006?
Keep it short and to the point. 1.12e+09. What is the difference between the Taxes (in $) in Bhutan in 2005 and the Taxes (in $) in Macao in 2006?
Offer a terse response. 8.38e+07. What is the difference between the Taxes (in $) in Bhutan in 2005 and the Taxes (in $) in Syrian Arab Republic in 2006?
Provide a succinct answer. -1.13e+11. What is the difference between the Taxes (in $) of Jordan in 2005 and the Taxes (in $) of Macao in 2006?
Keep it short and to the point. -1.16e+09. What is the difference between the Taxes (in $) in Jordan in 2005 and the Taxes (in $) in Syrian Arab Republic in 2006?
Provide a short and direct response. -1.15e+11. What is the difference between the Taxes (in $) of Macao in 2005 and the Taxes (in $) of Syrian Arab Republic in 2006?
Make the answer very short. -1.14e+11. What is the average Taxes (in $) in Bhutan per year?
Give a very brief answer. 1.29e+09. What is the average Taxes (in $) of Jordan per year?
Your response must be concise. 2.27e+08. What is the average Taxes (in $) in Macao per year?
Ensure brevity in your answer.  9.82e+08. What is the average Taxes (in $) in Syrian Arab Republic per year?
Your response must be concise. 1.11e+11. In the year 1999, what is the difference between the Taxes (in $) of Bhutan and Taxes (in $) of Jordan?
Keep it short and to the point. 5.72e+08. In the year 1999, what is the difference between the Taxes (in $) in Bhutan and Taxes (in $) in Macao?
Keep it short and to the point. -2.51e+08. In the year 1999, what is the difference between the Taxes (in $) in Bhutan and Taxes (in $) in Syrian Arab Republic?
Your answer should be very brief. -8.05e+1. In the year 1999, what is the difference between the Taxes (in $) in Jordan and Taxes (in $) in Macao?
Your answer should be compact. -8.23e+08. In the year 1999, what is the difference between the Taxes (in $) of Jordan and Taxes (in $) of Syrian Arab Republic?
Your response must be concise. -8.11e+1. In the year 1999, what is the difference between the Taxes (in $) of Macao and Taxes (in $) of Syrian Arab Republic?
Ensure brevity in your answer.  -8.02e+1. In the year 2000, what is the difference between the Taxes (in $) in Bhutan and Taxes (in $) in Jordan?
Make the answer very short. 8.96e+08. In the year 2000, what is the difference between the Taxes (in $) of Bhutan and Taxes (in $) of Macao?
Your response must be concise. 2.19e+08. In the year 2000, what is the difference between the Taxes (in $) of Bhutan and Taxes (in $) of Syrian Arab Republic?
Ensure brevity in your answer.  -9.34e+1. In the year 2000, what is the difference between the Taxes (in $) in Jordan and Taxes (in $) in Macao?
Your answer should be compact. -6.77e+08. In the year 2000, what is the difference between the Taxes (in $) of Jordan and Taxes (in $) of Syrian Arab Republic?
Your answer should be very brief. -9.43e+1. In the year 2000, what is the difference between the Taxes (in $) in Macao and Taxes (in $) in Syrian Arab Republic?
Offer a terse response. -9.36e+1. In the year 2001, what is the difference between the Taxes (in $) of Bhutan and Taxes (in $) of Jordan?
Offer a terse response. 9.96e+08. In the year 2001, what is the difference between the Taxes (in $) in Bhutan and Taxes (in $) in Macao?
Keep it short and to the point. 2.68e+08. In the year 2001, what is the difference between the Taxes (in $) in Bhutan and Taxes (in $) in Syrian Arab Republic?
Provide a short and direct response. -1.28e+11. In the year 2001, what is the difference between the Taxes (in $) of Jordan and Taxes (in $) of Macao?
Give a very brief answer. -7.28e+08. In the year 2001, what is the difference between the Taxes (in $) of Jordan and Taxes (in $) of Syrian Arab Republic?
Give a very brief answer. -1.29e+11. In the year 2001, what is the difference between the Taxes (in $) in Macao and Taxes (in $) in Syrian Arab Republic?
Offer a very short reply. -1.28e+11. In the year 2002, what is the difference between the Taxes (in $) of Bhutan and Taxes (in $) of Jordan?
Your response must be concise. 1.11e+09. In the year 2002, what is the difference between the Taxes (in $) of Bhutan and Taxes (in $) of Macao?
Your response must be concise. 4.32e+08. In the year 2002, what is the difference between the Taxes (in $) of Bhutan and Taxes (in $) of Syrian Arab Republic?
Keep it short and to the point. -1.14e+11. In the year 2002, what is the difference between the Taxes (in $) in Jordan and Taxes (in $) in Macao?
Offer a very short reply. -6.77e+08. In the year 2002, what is the difference between the Taxes (in $) of Jordan and Taxes (in $) of Syrian Arab Republic?
Your answer should be compact. -1.15e+11. In the year 2002, what is the difference between the Taxes (in $) in Macao and Taxes (in $) in Syrian Arab Republic?
Ensure brevity in your answer.  -1.15e+11. In the year 2003, what is the difference between the Taxes (in $) of Bhutan and Taxes (in $) of Jordan?
Offer a terse response. 1.08e+09. In the year 2003, what is the difference between the Taxes (in $) in Bhutan and Taxes (in $) in Macao?
Provide a succinct answer. 4.92e+08. In the year 2003, what is the difference between the Taxes (in $) of Bhutan and Taxes (in $) of Syrian Arab Republic?
Your answer should be very brief. -1.22e+11. In the year 2003, what is the difference between the Taxes (in $) in Jordan and Taxes (in $) in Macao?
Make the answer very short. -5.85e+08. In the year 2003, what is the difference between the Taxes (in $) of Jordan and Taxes (in $) of Syrian Arab Republic?
Offer a terse response. -1.23e+11. In the year 2003, what is the difference between the Taxes (in $) in Macao and Taxes (in $) in Syrian Arab Republic?
Provide a succinct answer. -1.23e+11. In the year 2004, what is the difference between the Taxes (in $) of Bhutan and Taxes (in $) of Jordan?
Offer a very short reply. 1.20e+09. In the year 2004, what is the difference between the Taxes (in $) of Bhutan and Taxes (in $) of Macao?
Provide a short and direct response. 4.52e+08. In the year 2004, what is the difference between the Taxes (in $) of Bhutan and Taxes (in $) of Syrian Arab Republic?
Give a very brief answer. -1.20e+11. In the year 2004, what is the difference between the Taxes (in $) in Jordan and Taxes (in $) in Macao?
Give a very brief answer. -7.50e+08. In the year 2004, what is the difference between the Taxes (in $) in Jordan and Taxes (in $) in Syrian Arab Republic?
Give a very brief answer. -1.21e+11. In the year 2004, what is the difference between the Taxes (in $) in Macao and Taxes (in $) in Syrian Arab Republic?
Offer a terse response. -1.21e+11. In the year 2005, what is the difference between the Taxes (in $) in Bhutan and Taxes (in $) in Jordan?
Make the answer very short. 1.25e+09. In the year 2005, what is the difference between the Taxes (in $) in Bhutan and Taxes (in $) in Macao?
Ensure brevity in your answer.  4.77e+08. In the year 2005, what is the difference between the Taxes (in $) of Bhutan and Taxes (in $) of Syrian Arab Republic?
Your answer should be compact. -1.06e+11. In the year 2005, what is the difference between the Taxes (in $) in Jordan and Taxes (in $) in Macao?
Keep it short and to the point. -7.69e+08. In the year 2005, what is the difference between the Taxes (in $) in Jordan and Taxes (in $) in Syrian Arab Republic?
Ensure brevity in your answer.  -1.07e+11. In the year 2005, what is the difference between the Taxes (in $) in Macao and Taxes (in $) in Syrian Arab Republic?
Give a very brief answer. -1.06e+11. In the year 2006, what is the difference between the Taxes (in $) of Bhutan and Taxes (in $) of Jordan?
Keep it short and to the point. 1.42e+09. In the year 2006, what is the difference between the Taxes (in $) of Bhutan and Taxes (in $) of Macao?
Ensure brevity in your answer.  3.87e+08. In the year 2006, what is the difference between the Taxes (in $) in Bhutan and Taxes (in $) in Syrian Arab Republic?
Your response must be concise. -1.13e+11. In the year 2006, what is the difference between the Taxes (in $) in Jordan and Taxes (in $) in Macao?
Offer a terse response. -1.03e+09. In the year 2006, what is the difference between the Taxes (in $) of Jordan and Taxes (in $) of Syrian Arab Republic?
Provide a succinct answer. -1.15e+11. In the year 2006, what is the difference between the Taxes (in $) of Macao and Taxes (in $) of Syrian Arab Republic?
Provide a succinct answer. -1.14e+11. What is the ratio of the Taxes (in $) in Bhutan in 1999 to that in 2000?
Your response must be concise. 0.69. What is the ratio of the Taxes (in $) in Jordan in 1999 to that in 2000?
Offer a terse response. 0.95. What is the ratio of the Taxes (in $) of Macao in 1999 to that in 2000?
Provide a succinct answer. 1.16. What is the ratio of the Taxes (in $) in Syrian Arab Republic in 1999 to that in 2000?
Ensure brevity in your answer.  0.86. What is the ratio of the Taxes (in $) in Bhutan in 1999 to that in 2001?
Your answer should be compact. 0.61. What is the ratio of the Taxes (in $) in Jordan in 1999 to that in 2001?
Keep it short and to the point. 0.78. What is the ratio of the Taxes (in $) of Macao in 1999 to that in 2001?
Provide a succinct answer. 1.06. What is the ratio of the Taxes (in $) of Syrian Arab Republic in 1999 to that in 2001?
Your response must be concise. 0.63. What is the ratio of the Taxes (in $) in Bhutan in 1999 to that in 2002?
Keep it short and to the point. 0.56. What is the ratio of the Taxes (in $) in Jordan in 1999 to that in 2002?
Your answer should be very brief. 0.78. What is the ratio of the Taxes (in $) of Macao in 1999 to that in 2002?
Make the answer very short. 1.12. What is the ratio of the Taxes (in $) in Syrian Arab Republic in 1999 to that in 2002?
Give a very brief answer. 0.7. What is the ratio of the Taxes (in $) of Bhutan in 1999 to that in 2003?
Your response must be concise. 0.57. What is the ratio of the Taxes (in $) in Jordan in 1999 to that in 2003?
Make the answer very short. 0.78. What is the ratio of the Taxes (in $) in Macao in 1999 to that in 2003?
Give a very brief answer. 1.25. What is the ratio of the Taxes (in $) in Syrian Arab Republic in 1999 to that in 2003?
Give a very brief answer. 0.66. What is the ratio of the Taxes (in $) of Bhutan in 1999 to that in 2004?
Offer a very short reply. 0.51. What is the ratio of the Taxes (in $) in Jordan in 1999 to that in 2004?
Your answer should be compact. 0.7. What is the ratio of the Taxes (in $) of Macao in 1999 to that in 2004?
Your answer should be compact. 1.01. What is the ratio of the Taxes (in $) in Syrian Arab Republic in 1999 to that in 2004?
Your answer should be very brief. 0.67. What is the ratio of the Taxes (in $) in Bhutan in 1999 to that in 2005?
Give a very brief answer. 0.47. What is the ratio of the Taxes (in $) in Jordan in 1999 to that in 2005?
Give a very brief answer. 0.54. What is the ratio of the Taxes (in $) of Macao in 1999 to that in 2005?
Provide a short and direct response. 0.93. What is the ratio of the Taxes (in $) of Syrian Arab Republic in 1999 to that in 2005?
Keep it short and to the point. 0.76. What is the ratio of the Taxes (in $) in Bhutan in 1999 to that in 2006?
Give a very brief answer. 0.4. What is the ratio of the Taxes (in $) in Jordan in 1999 to that in 2006?
Provide a short and direct response. 0.37. What is the ratio of the Taxes (in $) of Macao in 1999 to that in 2006?
Your answer should be very brief. 0.67. What is the ratio of the Taxes (in $) in Syrian Arab Republic in 1999 to that in 2006?
Your response must be concise. 0.71. What is the ratio of the Taxes (in $) of Bhutan in 2000 to that in 2001?
Offer a terse response. 0.89. What is the ratio of the Taxes (in $) of Jordan in 2000 to that in 2001?
Your response must be concise. 0.82. What is the ratio of the Taxes (in $) in Macao in 2000 to that in 2001?
Keep it short and to the point. 0.91. What is the ratio of the Taxes (in $) of Syrian Arab Republic in 2000 to that in 2001?
Offer a terse response. 0.73. What is the ratio of the Taxes (in $) of Bhutan in 2000 to that in 2002?
Your response must be concise. 0.81. What is the ratio of the Taxes (in $) in Jordan in 2000 to that in 2002?
Make the answer very short. 0.82. What is the ratio of the Taxes (in $) of Macao in 2000 to that in 2002?
Offer a terse response. 0.96. What is the ratio of the Taxes (in $) in Syrian Arab Republic in 2000 to that in 2002?
Provide a short and direct response. 0.82. What is the ratio of the Taxes (in $) of Bhutan in 2000 to that in 2003?
Make the answer very short. 0.83. What is the ratio of the Taxes (in $) in Jordan in 2000 to that in 2003?
Provide a short and direct response. 0.82. What is the ratio of the Taxes (in $) of Macao in 2000 to that in 2003?
Your answer should be compact. 1.07. What is the ratio of the Taxes (in $) of Syrian Arab Republic in 2000 to that in 2003?
Your answer should be very brief. 0.77. What is the ratio of the Taxes (in $) in Bhutan in 2000 to that in 2004?
Your answer should be compact. 0.74. What is the ratio of the Taxes (in $) in Jordan in 2000 to that in 2004?
Keep it short and to the point. 0.74. What is the ratio of the Taxes (in $) in Macao in 2000 to that in 2004?
Your response must be concise. 0.87. What is the ratio of the Taxes (in $) in Syrian Arab Republic in 2000 to that in 2004?
Provide a succinct answer. 0.78. What is the ratio of the Taxes (in $) in Bhutan in 2000 to that in 2005?
Your answer should be very brief. 0.69. What is the ratio of the Taxes (in $) in Jordan in 2000 to that in 2005?
Your answer should be very brief. 0.57. What is the ratio of the Taxes (in $) of Macao in 2000 to that in 2005?
Your answer should be compact. 0.8. What is the ratio of the Taxes (in $) in Syrian Arab Republic in 2000 to that in 2005?
Provide a succinct answer. 0.88. What is the ratio of the Taxes (in $) of Bhutan in 2000 to that in 2006?
Your response must be concise. 0.58. What is the ratio of the Taxes (in $) of Jordan in 2000 to that in 2006?
Offer a terse response. 0.39. What is the ratio of the Taxes (in $) of Macao in 2000 to that in 2006?
Offer a terse response. 0.58. What is the ratio of the Taxes (in $) in Syrian Arab Republic in 2000 to that in 2006?
Keep it short and to the point. 0.82. What is the ratio of the Taxes (in $) in Bhutan in 2001 to that in 2002?
Give a very brief answer. 0.91. What is the ratio of the Taxes (in $) of Jordan in 2001 to that in 2002?
Make the answer very short. 1. What is the ratio of the Taxes (in $) of Macao in 2001 to that in 2002?
Your answer should be very brief. 1.06. What is the ratio of the Taxes (in $) in Syrian Arab Republic in 2001 to that in 2002?
Your answer should be very brief. 1.12. What is the ratio of the Taxes (in $) in Bhutan in 2001 to that in 2003?
Provide a succinct answer. 0.94. What is the ratio of the Taxes (in $) of Macao in 2001 to that in 2003?
Provide a short and direct response. 1.18. What is the ratio of the Taxes (in $) in Syrian Arab Republic in 2001 to that in 2003?
Provide a short and direct response. 1.05. What is the ratio of the Taxes (in $) in Bhutan in 2001 to that in 2004?
Provide a succinct answer. 0.84. What is the ratio of the Taxes (in $) of Jordan in 2001 to that in 2004?
Offer a very short reply. 0.9. What is the ratio of the Taxes (in $) in Macao in 2001 to that in 2004?
Keep it short and to the point. 0.95. What is the ratio of the Taxes (in $) of Syrian Arab Republic in 2001 to that in 2004?
Offer a very short reply. 1.06. What is the ratio of the Taxes (in $) of Bhutan in 2001 to that in 2005?
Your response must be concise. 0.78. What is the ratio of the Taxes (in $) of Jordan in 2001 to that in 2005?
Give a very brief answer. 0.69. What is the ratio of the Taxes (in $) of Macao in 2001 to that in 2005?
Provide a short and direct response. 0.88. What is the ratio of the Taxes (in $) in Syrian Arab Republic in 2001 to that in 2005?
Make the answer very short. 1.2. What is the ratio of the Taxes (in $) in Bhutan in 2001 to that in 2006?
Your answer should be compact. 0.65. What is the ratio of the Taxes (in $) of Jordan in 2001 to that in 2006?
Offer a terse response. 0.47. What is the ratio of the Taxes (in $) in Macao in 2001 to that in 2006?
Ensure brevity in your answer.  0.64. What is the ratio of the Taxes (in $) of Syrian Arab Republic in 2001 to that in 2006?
Your response must be concise. 1.12. What is the ratio of the Taxes (in $) of Bhutan in 2002 to that in 2003?
Provide a succinct answer. 1.03. What is the ratio of the Taxes (in $) of Macao in 2002 to that in 2003?
Ensure brevity in your answer.  1.12. What is the ratio of the Taxes (in $) of Syrian Arab Republic in 2002 to that in 2003?
Offer a terse response. 0.94. What is the ratio of the Taxes (in $) in Bhutan in 2002 to that in 2004?
Your answer should be compact. 0.92. What is the ratio of the Taxes (in $) in Jordan in 2002 to that in 2004?
Make the answer very short. 0.9. What is the ratio of the Taxes (in $) in Macao in 2002 to that in 2004?
Give a very brief answer. 0.9. What is the ratio of the Taxes (in $) in Syrian Arab Republic in 2002 to that in 2004?
Provide a short and direct response. 0.95. What is the ratio of the Taxes (in $) in Bhutan in 2002 to that in 2005?
Provide a short and direct response. 0.85. What is the ratio of the Taxes (in $) in Jordan in 2002 to that in 2005?
Your answer should be very brief. 0.69. What is the ratio of the Taxes (in $) of Macao in 2002 to that in 2005?
Provide a short and direct response. 0.83. What is the ratio of the Taxes (in $) of Syrian Arab Republic in 2002 to that in 2005?
Offer a very short reply. 1.08. What is the ratio of the Taxes (in $) of Bhutan in 2002 to that in 2006?
Your answer should be compact. 0.71. What is the ratio of the Taxes (in $) of Jordan in 2002 to that in 2006?
Ensure brevity in your answer.  0.48. What is the ratio of the Taxes (in $) of Macao in 2002 to that in 2006?
Make the answer very short. 0.6. What is the ratio of the Taxes (in $) in Bhutan in 2003 to that in 2004?
Your answer should be very brief. 0.9. What is the ratio of the Taxes (in $) in Jordan in 2003 to that in 2004?
Offer a terse response. 0.9. What is the ratio of the Taxes (in $) in Macao in 2003 to that in 2004?
Your response must be concise. 0.81. What is the ratio of the Taxes (in $) of Bhutan in 2003 to that in 2005?
Keep it short and to the point. 0.83. What is the ratio of the Taxes (in $) in Jordan in 2003 to that in 2005?
Your answer should be very brief. 0.69. What is the ratio of the Taxes (in $) in Macao in 2003 to that in 2005?
Ensure brevity in your answer.  0.74. What is the ratio of the Taxes (in $) of Syrian Arab Republic in 2003 to that in 2005?
Offer a terse response. 1.15. What is the ratio of the Taxes (in $) in Bhutan in 2003 to that in 2006?
Keep it short and to the point. 0.69. What is the ratio of the Taxes (in $) of Jordan in 2003 to that in 2006?
Ensure brevity in your answer.  0.47. What is the ratio of the Taxes (in $) in Macao in 2003 to that in 2006?
Offer a very short reply. 0.54. What is the ratio of the Taxes (in $) in Syrian Arab Republic in 2003 to that in 2006?
Your answer should be very brief. 1.07. What is the ratio of the Taxes (in $) of Bhutan in 2004 to that in 2005?
Keep it short and to the point. 0.93. What is the ratio of the Taxes (in $) of Jordan in 2004 to that in 2005?
Offer a very short reply. 0.77. What is the ratio of the Taxes (in $) in Macao in 2004 to that in 2005?
Keep it short and to the point. 0.92. What is the ratio of the Taxes (in $) of Syrian Arab Republic in 2004 to that in 2005?
Provide a short and direct response. 1.13. What is the ratio of the Taxes (in $) of Bhutan in 2004 to that in 2006?
Give a very brief answer. 0.77. What is the ratio of the Taxes (in $) of Jordan in 2004 to that in 2006?
Give a very brief answer. 0.53. What is the ratio of the Taxes (in $) in Macao in 2004 to that in 2006?
Your response must be concise. 0.67. What is the ratio of the Taxes (in $) of Syrian Arab Republic in 2004 to that in 2006?
Provide a short and direct response. 1.06. What is the ratio of the Taxes (in $) of Bhutan in 2005 to that in 2006?
Ensure brevity in your answer.  0.83. What is the ratio of the Taxes (in $) in Jordan in 2005 to that in 2006?
Provide a succinct answer. 0.69. What is the ratio of the Taxes (in $) in Macao in 2005 to that in 2006?
Offer a very short reply. 0.73. What is the ratio of the Taxes (in $) in Syrian Arab Republic in 2005 to that in 2006?
Provide a short and direct response. 0.93. What is the difference between the highest and the second highest Taxes (in $) of Bhutan?
Your answer should be very brief. 3.03e+08. What is the difference between the highest and the second highest Taxes (in $) in Jordan?
Your answer should be very brief. 1.28e+08. What is the difference between the highest and the second highest Taxes (in $) of Macao?
Your answer should be compact. 3.93e+08. What is the difference between the highest and the second highest Taxes (in $) of Syrian Arab Republic?
Provide a succinct answer. 5.89e+09. What is the difference between the highest and the lowest Taxes (in $) of Bhutan?
Offer a very short reply. 1.11e+09. What is the difference between the highest and the lowest Taxes (in $) of Jordan?
Provide a short and direct response. 2.59e+08. What is the difference between the highest and the lowest Taxes (in $) of Macao?
Offer a terse response. 6.65e+08. What is the difference between the highest and the lowest Taxes (in $) in Syrian Arab Republic?
Give a very brief answer. 4.80e+1. 